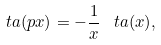Convert formula to latex. <formula><loc_0><loc_0><loc_500><loc_500>\ t a ( p x ) = - \frac { 1 } { x } \, \ t a ( x ) ,</formula> 